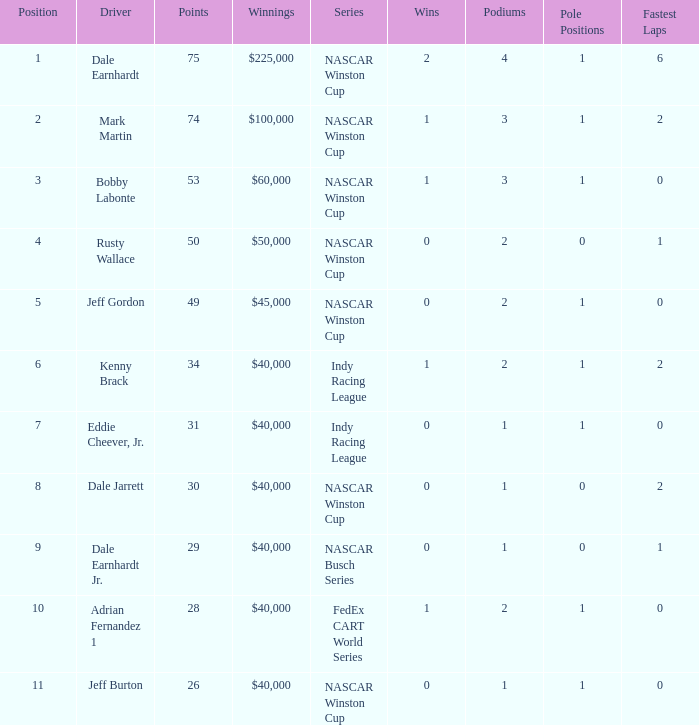How much did Jeff Burton win? $40,000. 